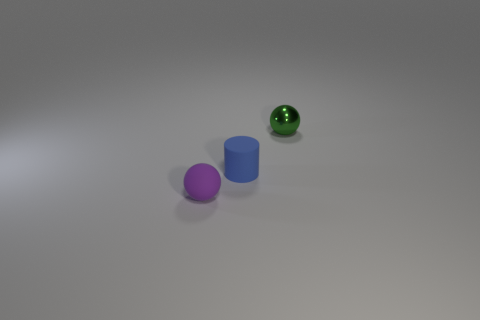Add 2 small cylinders. How many objects exist? 5 Subtract all cylinders. How many objects are left? 2 Subtract all tiny purple balls. Subtract all tiny spheres. How many objects are left? 0 Add 1 tiny purple spheres. How many tiny purple spheres are left? 2 Add 1 big blue metallic blocks. How many big blue metallic blocks exist? 1 Subtract 0 blue blocks. How many objects are left? 3 